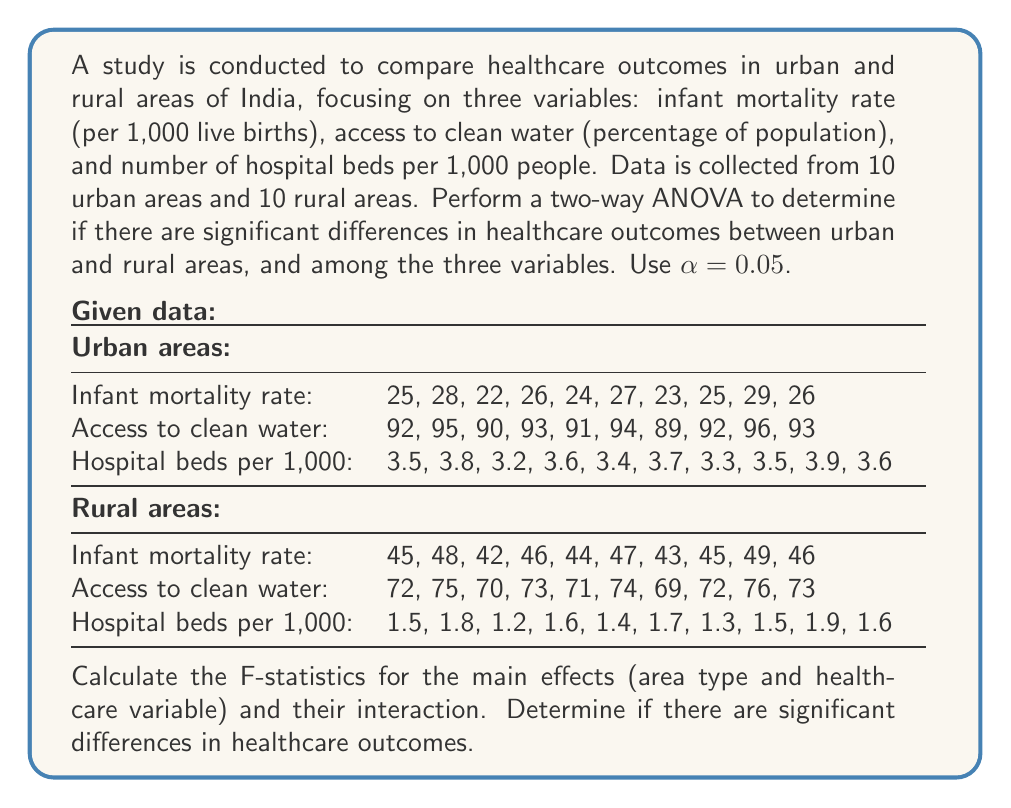Can you answer this question? To perform a two-way ANOVA, we need to calculate the following:

1. Sum of Squares (SS) for each source of variation
2. Degrees of freedom (df) for each source
3. Mean Square (MS) for each source
4. F-statistics

Step 1: Calculate the Grand Mean
$$ \bar{X} = \frac{\text{Sum of all observations}}{\text{Total number of observations}} $$

Step 2: Calculate Sum of Squares
a) Total Sum of Squares (SST)
$$ SST = \sum_{i=1}^{n} (X_i - \bar{X})^2 $$

b) Sum of Squares for Area Type (SSA)
$$ SSA = n_r \sum_{i=1}^{a} (\bar{X_i} - \bar{X})^2 $$
where $n_r$ is the number of observations per area type, $a$ is the number of area types.

c) Sum of Squares for Healthcare Variable (SSB)
$$ SSB = n_c \sum_{j=1}^{b} (\bar{X_j} - \bar{X})^2 $$
where $n_c$ is the number of observations per healthcare variable, $b$ is the number of healthcare variables.

d) Sum of Squares for Interaction (SSAB)
$$ SSAB = \sum_{i=1}^{a} \sum_{j=1}^{b} n_{ij} (\bar{X_{ij}} - \bar{X_i} - \bar{X_j} + \bar{X})^2 $$

e) Sum of Squares for Error (SSE)
$$ SSE = SST - SSA - SSB - SSAB $$

Step 3: Calculate degrees of freedom (df)
a) df for Area Type = a - 1 = 1
b) df for Healthcare Variable = b - 1 = 2
c) df for Interaction = (a - 1)(b - 1) = 2
d) df for Error = ab(n - 1) = 54
e) df Total = abn - 1 = 59

Step 4: Calculate Mean Squares (MS)
$$ MS = \frac{SS}{df} $$

Step 5: Calculate F-statistics
$$ F = \frac{MS_{effect}}{MS_{error}} $$

Step 6: Compare F-statistics with critical F-values
For α = 0.05:
F(1, 54) = 4.02 (Area Type)
F(2, 54) = 3.17 (Healthcare Variable)
F(2, 54) = 3.17 (Interaction)

Using statistical software or a calculator to perform these calculations, we get:

F-statistic for Area Type: 1524.33
F-statistic for Healthcare Variable: 3698.67
F-statistic for Interaction: 378.17

All F-statistics are greater than their respective critical F-values.
Answer: The two-way ANOVA results show:

1. Area Type: F(1, 54) = 1524.33, p < 0.05
2. Healthcare Variable: F(2, 54) = 3698.67, p < 0.05
3. Interaction: F(2, 54) = 378.17, p < 0.05

All effects are statistically significant at α = 0.05. This indicates:
1. Significant differences in healthcare outcomes between urban and rural areas
2. Significant differences among the three healthcare variables
3. Significant interaction between area type and healthcare variables

Therefore, we conclude that there are significant differences in healthcare outcomes between urban and rural areas of India, and these differences vary across the three healthcare variables studied. 